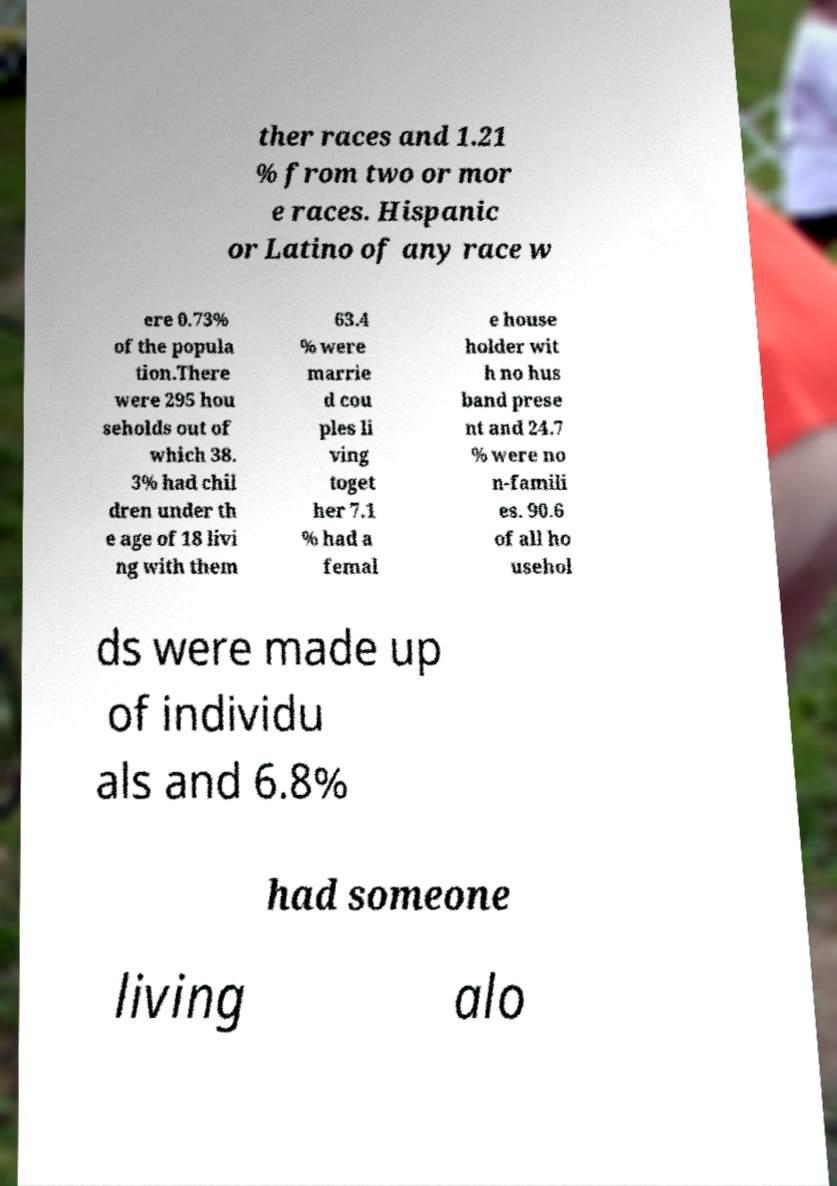I need the written content from this picture converted into text. Can you do that? ther races and 1.21 % from two or mor e races. Hispanic or Latino of any race w ere 0.73% of the popula tion.There were 295 hou seholds out of which 38. 3% had chil dren under th e age of 18 livi ng with them 63.4 % were marrie d cou ples li ving toget her 7.1 % had a femal e house holder wit h no hus band prese nt and 24.7 % were no n-famili es. 90.6 of all ho usehol ds were made up of individu als and 6.8% had someone living alo 